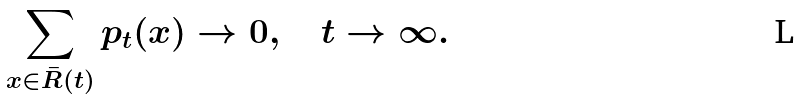<formula> <loc_0><loc_0><loc_500><loc_500>\sum _ { x \in \bar { R } ( t ) } p _ { t } ( x ) \to 0 , \quad t \to \infty .</formula> 